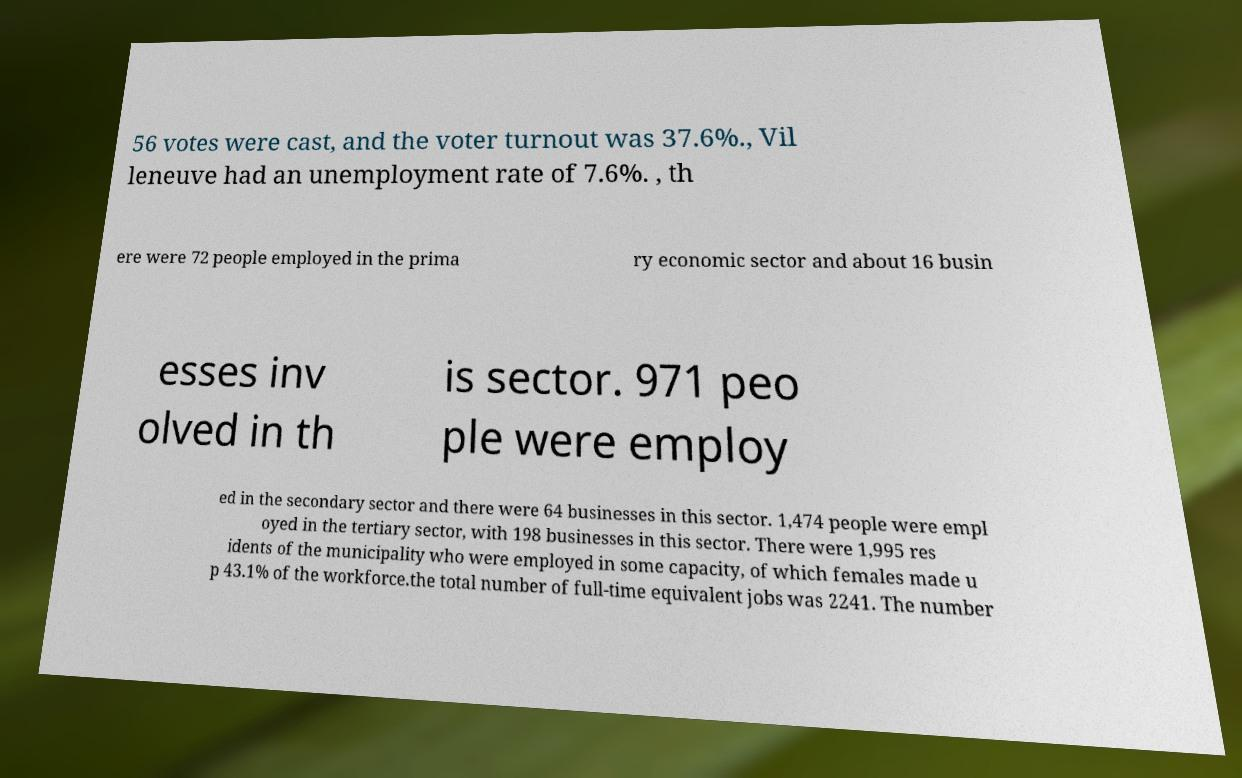Can you accurately transcribe the text from the provided image for me? 56 votes were cast, and the voter turnout was 37.6%., Vil leneuve had an unemployment rate of 7.6%. , th ere were 72 people employed in the prima ry economic sector and about 16 busin esses inv olved in th is sector. 971 peo ple were employ ed in the secondary sector and there were 64 businesses in this sector. 1,474 people were empl oyed in the tertiary sector, with 198 businesses in this sector. There were 1,995 res idents of the municipality who were employed in some capacity, of which females made u p 43.1% of the workforce.the total number of full-time equivalent jobs was 2241. The number 